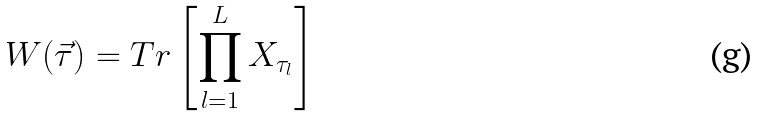Convert formula to latex. <formula><loc_0><loc_0><loc_500><loc_500>W ( { \vec { \tau } } ) = T r \left [ \prod _ { l = 1 } ^ { L } X _ { \tau _ { l } } \right ]</formula> 